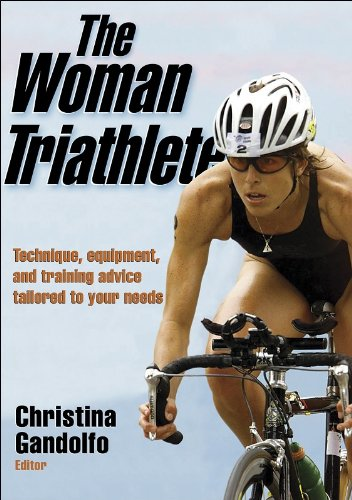What is the genre of this book? The genre of 'The Woman Triathlete' falls under Sports & Outdoors, with a specific emphasis on triathlon training and advice geared towards female athletes. 